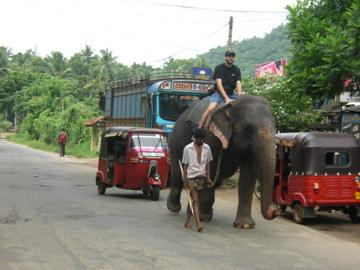The white man is most likely what? Please explain your reasoning. tourist. As he is not the same nationality as the man leading the elephant, it is probably safe to assume he is visiting the area. 